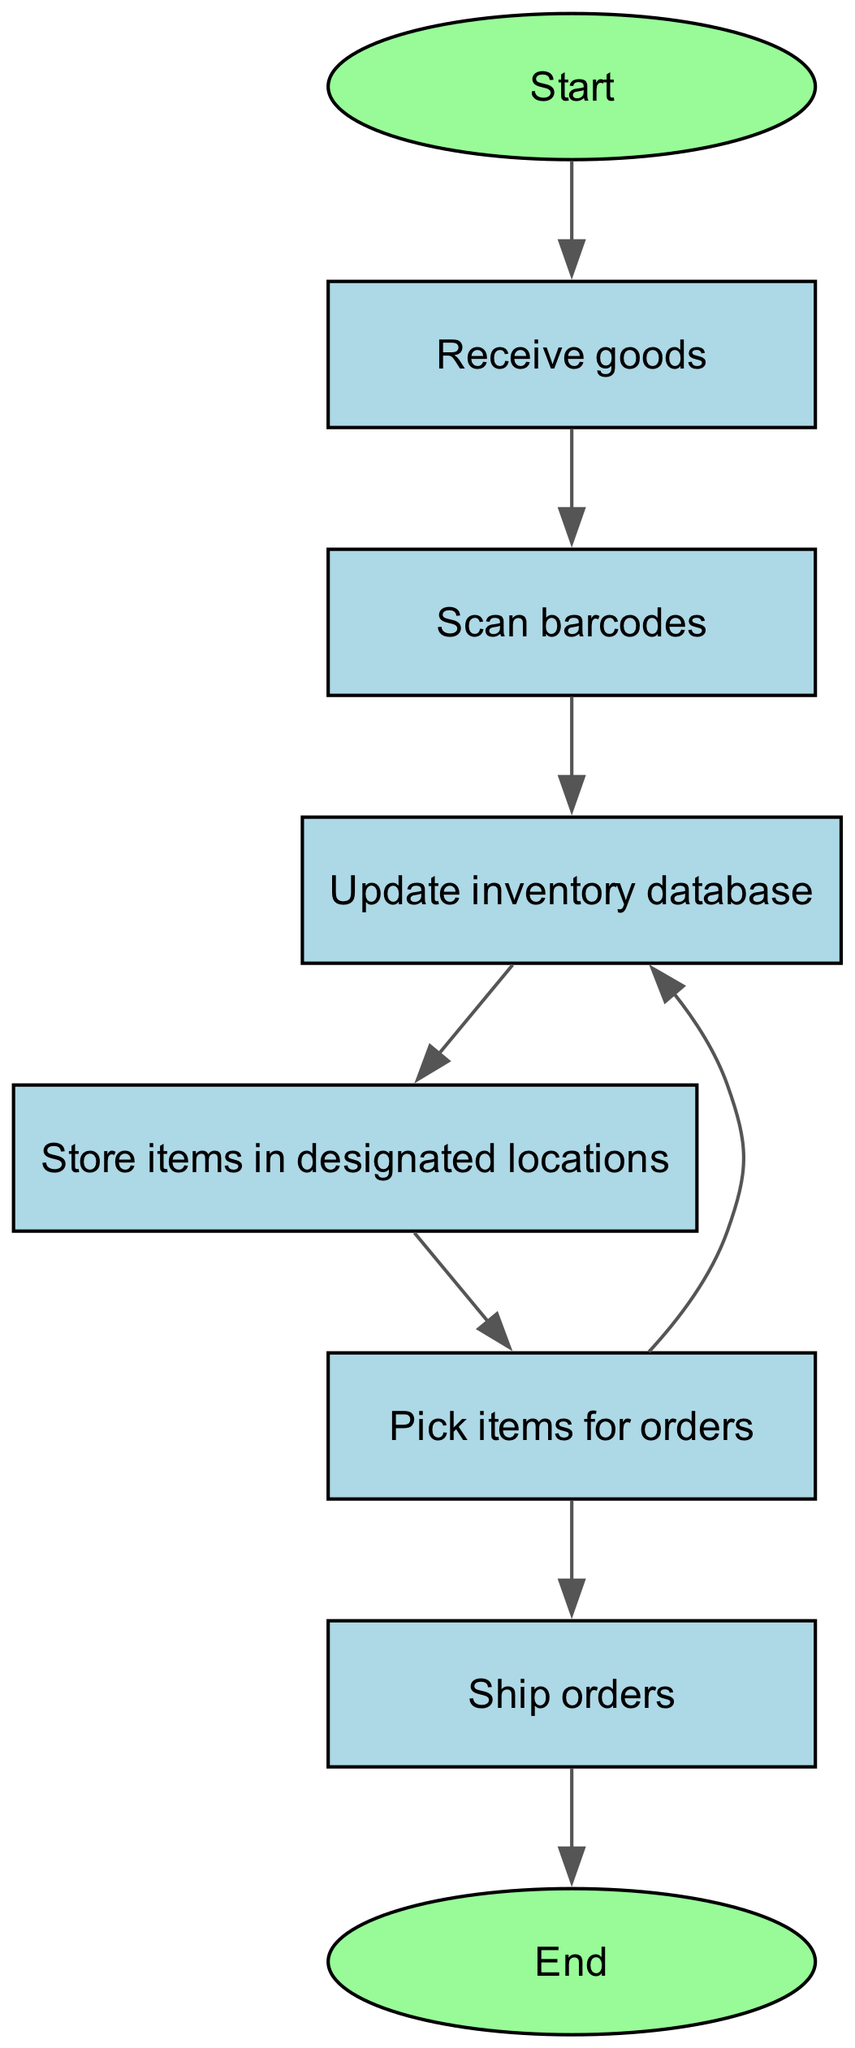What is the first step in the warehouse inventory management process? The first step in the diagram is labeled "Start", which leads to the action of receiving goods.
Answer: Receive goods How many nodes are present in the flowchart? The flowchart contains eight nodes: Start, Receive goods, Scan barcodes, Update inventory database, Store items in designated locations, Pick items for orders, Ship orders, and End.
Answer: Eight What action follows after scanning barcodes? From the "Scan barcodes" node, the next action is "Update inventory database". This indicates the sequential flow of the process.
Answer: Update inventory database Which two actions can be taken after picking items for orders? After "Pick items for orders", the process can either go to "Update inventory database" or "Ship orders", showing that picking items can lead to two possible paths.
Answer: Update inventory database, Ship orders What is the last step in the inventory management process? The diagram indicates that after shipping orders, the final step is represented by the "End" node, concluding the process.
Answer: End How does the process flow from receiving goods to shipping orders? The flow goes from "Receive goods" to "Scan barcodes", then to "Update inventory database", followed by "Store items in designated locations", then to "Pick items for orders", and finally to "Ship orders".
Answer: Receive goods → Scan barcodes → Update inventory database → Store items in designated locations → Pick items for orders → Ship orders 